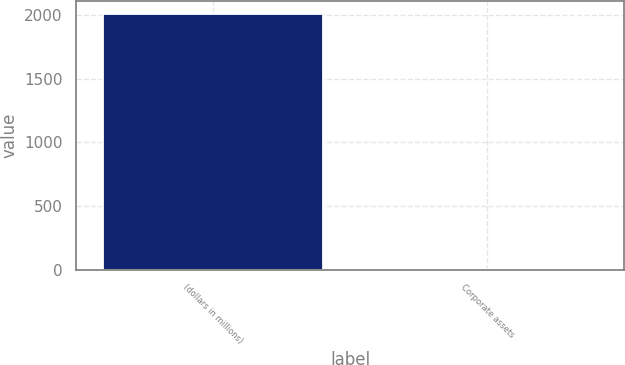Convert chart. <chart><loc_0><loc_0><loc_500><loc_500><bar_chart><fcel>(dollars in millions)<fcel>Corporate assets<nl><fcel>2010<fcel>1.9<nl></chart> 